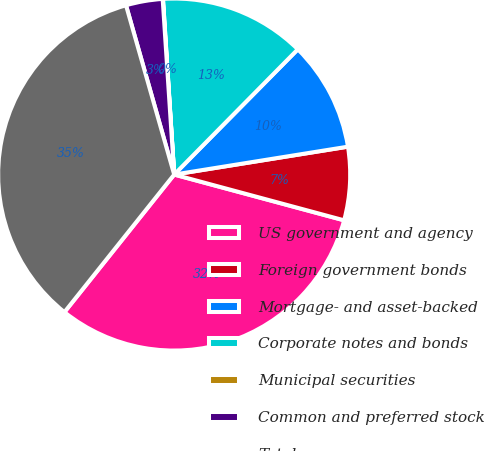<chart> <loc_0><loc_0><loc_500><loc_500><pie_chart><fcel>US government and agency<fcel>Foreign government bonds<fcel>Mortgage- and asset-backed<fcel>Corporate notes and bonds<fcel>Municipal securities<fcel>Common and preferred stock<fcel>Total<nl><fcel>31.53%<fcel>6.72%<fcel>10.07%<fcel>13.41%<fcel>0.03%<fcel>3.37%<fcel>34.87%<nl></chart> 